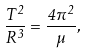<formula> <loc_0><loc_0><loc_500><loc_500>\frac { T ^ { 2 } } { R ^ { 3 } } = \frac { 4 \pi ^ { 2 } } { \mu } ,</formula> 